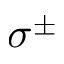Convert formula to latex. <formula><loc_0><loc_0><loc_500><loc_500>\sigma ^ { \pm }</formula> 